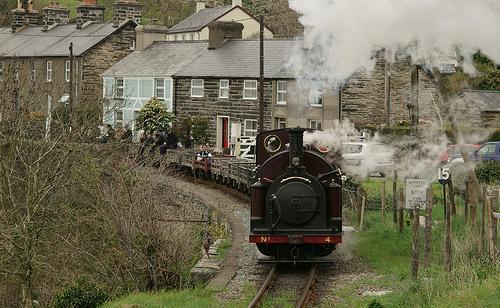How many trains are in the picture?
Give a very brief answer. 1. 